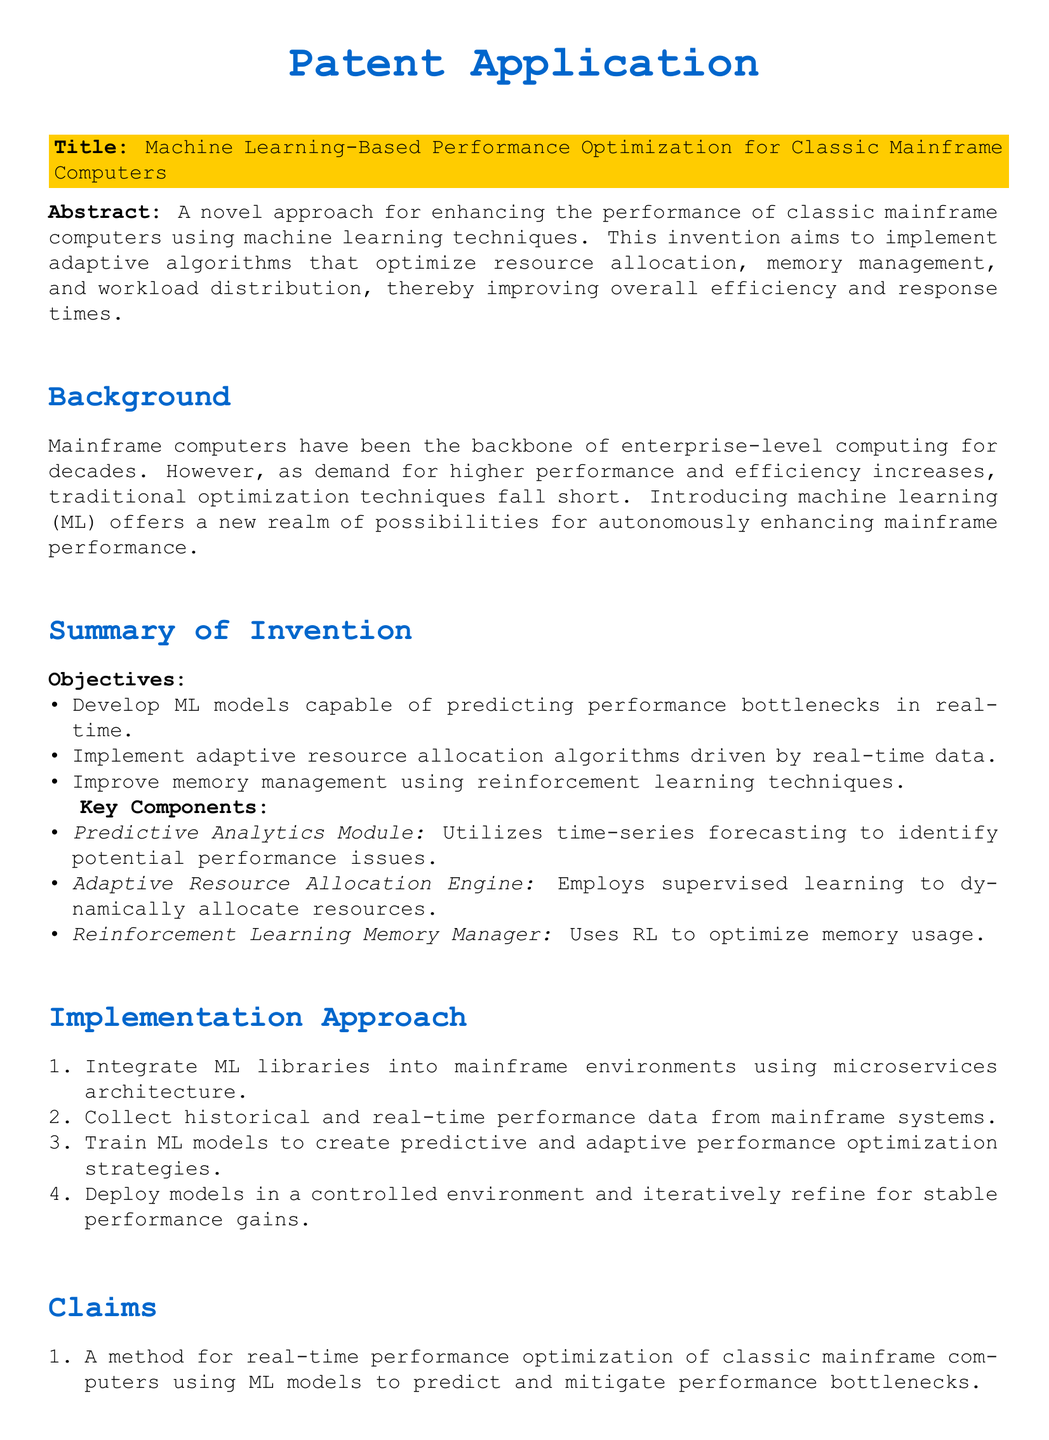What is the title of the patent application? The title is provided in the document as a key piece of information.
Answer: Machine Learning-Based Performance Optimization for Classic Mainframe Computers What are the objectives of the invention? The objectives are listed in the summary of the invention section.
Answer: Develop ML models capable of predicting performance bottlenecks in real-time, Implement adaptive resource allocation algorithms driven by real-time data, Improve memory management using reinforcement learning techniques What module uses time-series forecasting? The specific module utilizing time-series forecasting is identified in the key components section.
Answer: Predictive Analytics Module How many claims are included in the patent application? The total number of claims is specified in the claims section of the document.
Answer: Three What technology is employed for memory management? The document specifies the technology used for memory management in the summary of the invention.
Answer: Reinforcement learning techniques What is the first step in the implementation approach? The implementation approach outlines specific steps, and the first step is mentioned clearly.
Answer: Integrate ML libraries into mainframe environments using microservices architecture Which learning method is used for the resource allocation engine? The document explicitly states the learning method for the resource allocation engine in its description.
Answer: Supervised learning What is the primary goal of this invention? The primary goal is summarized in the abstract at the beginning of the document.
Answer: Enhancing the performance of classic mainframe computers using machine learning techniques 